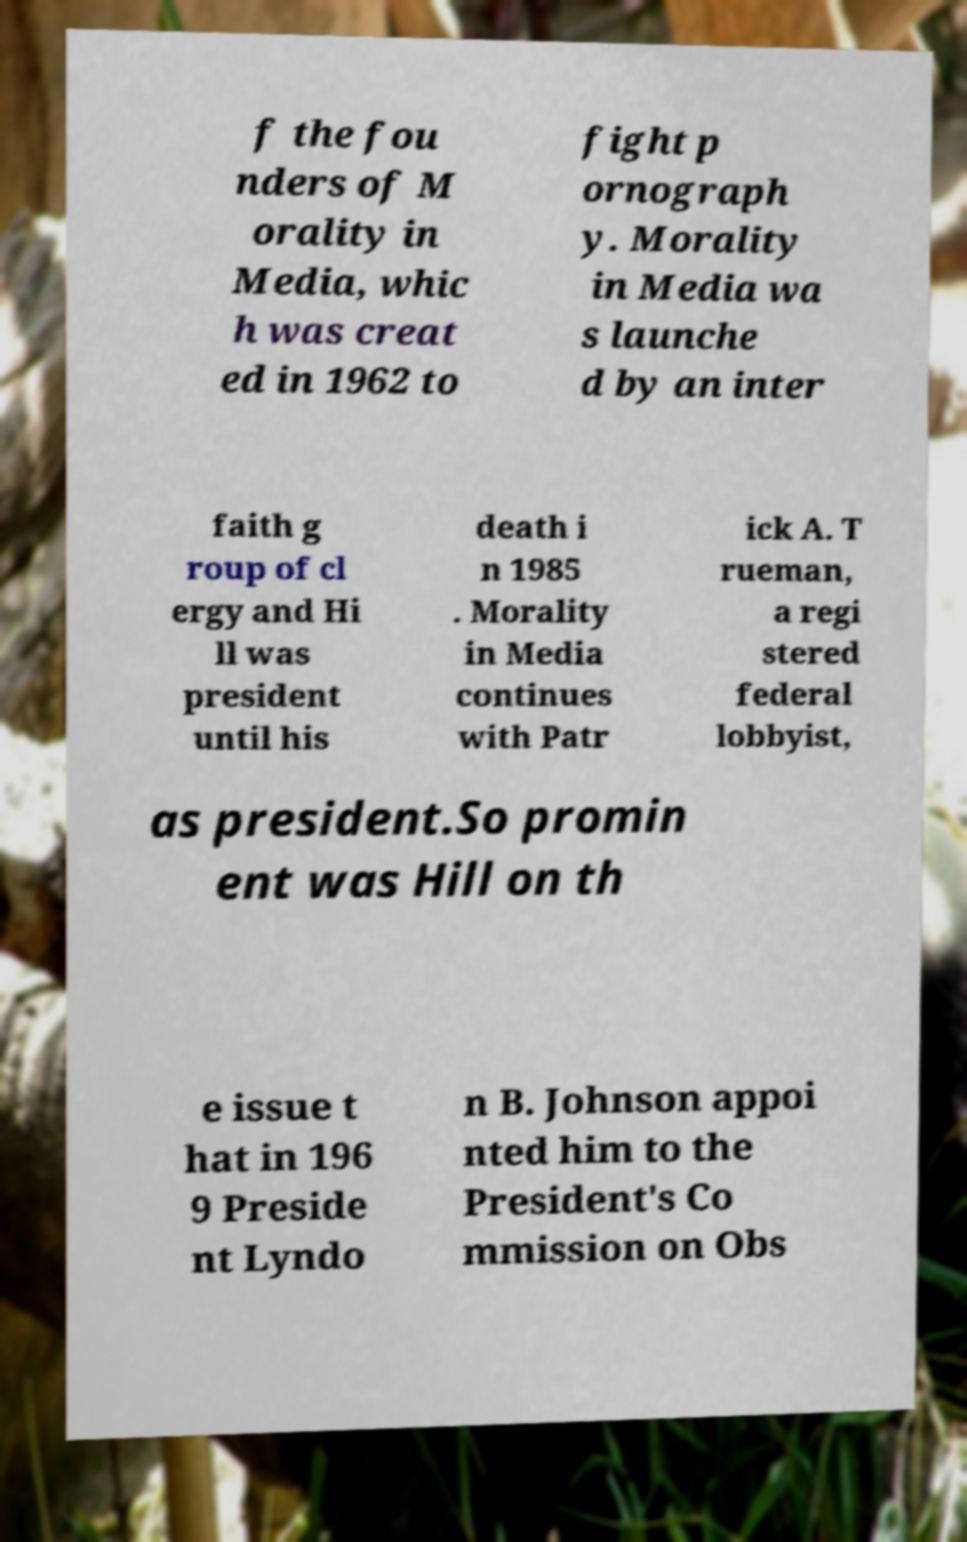Could you assist in decoding the text presented in this image and type it out clearly? f the fou nders of M orality in Media, whic h was creat ed in 1962 to fight p ornograph y. Morality in Media wa s launche d by an inter faith g roup of cl ergy and Hi ll was president until his death i n 1985 . Morality in Media continues with Patr ick A. T rueman, a regi stered federal lobbyist, as president.So promin ent was Hill on th e issue t hat in 196 9 Preside nt Lyndo n B. Johnson appoi nted him to the President's Co mmission on Obs 